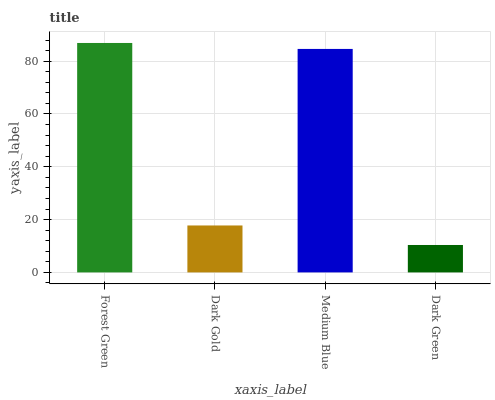Is Dark Green the minimum?
Answer yes or no. Yes. Is Forest Green the maximum?
Answer yes or no. Yes. Is Dark Gold the minimum?
Answer yes or no. No. Is Dark Gold the maximum?
Answer yes or no. No. Is Forest Green greater than Dark Gold?
Answer yes or no. Yes. Is Dark Gold less than Forest Green?
Answer yes or no. Yes. Is Dark Gold greater than Forest Green?
Answer yes or no. No. Is Forest Green less than Dark Gold?
Answer yes or no. No. Is Medium Blue the high median?
Answer yes or no. Yes. Is Dark Gold the low median?
Answer yes or no. Yes. Is Dark Green the high median?
Answer yes or no. No. Is Dark Green the low median?
Answer yes or no. No. 